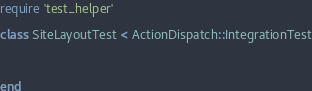Convert code to text. <code><loc_0><loc_0><loc_500><loc_500><_Ruby_>require 'test_helper'

class SiteLayoutTest < ActionDispatch::IntegrationTest
  
  
  
end
</code> 